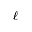<formula> <loc_0><loc_0><loc_500><loc_500>\ell</formula> 